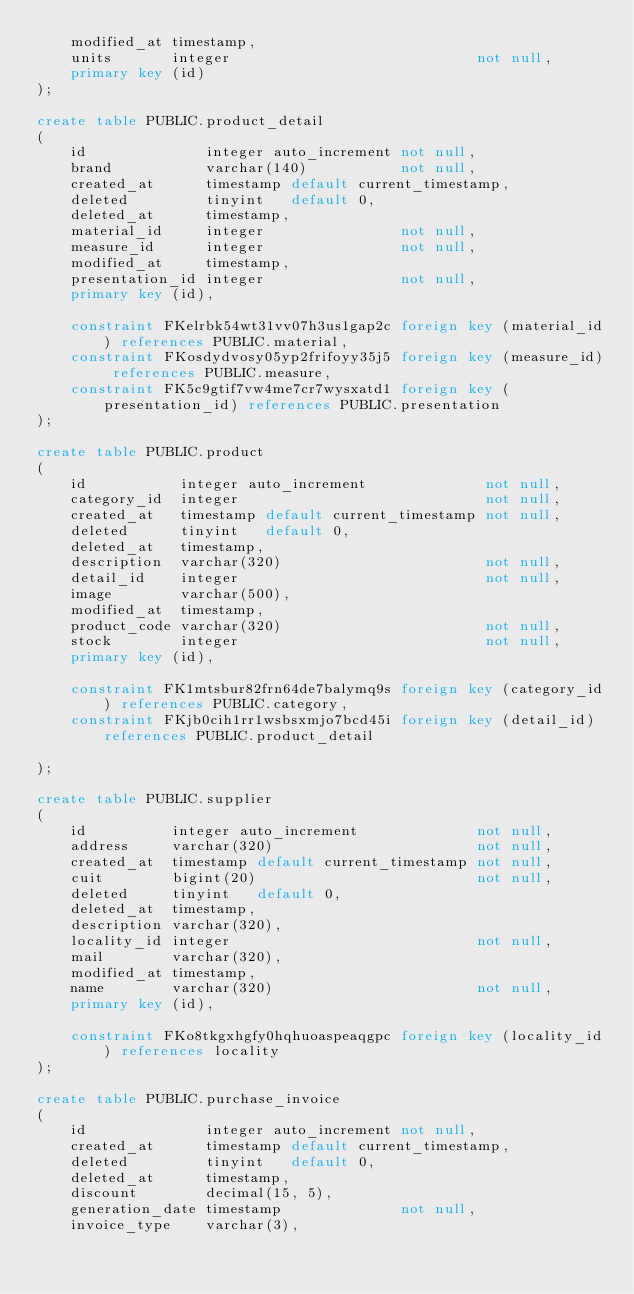Convert code to text. <code><loc_0><loc_0><loc_500><loc_500><_SQL_>    modified_at timestamp,
    units       integer                             not null,
    primary key (id)
);

create table PUBLIC.product_detail
(
    id              integer auto_increment not null,
    brand           varchar(140)           not null,
    created_at      timestamp default current_timestamp,
    deleted         tinyint   default 0,
    deleted_at      timestamp,
    material_id     integer                not null,
    measure_id      integer                not null,
    modified_at     timestamp,
    presentation_id integer                not null,
    primary key (id),

    constraint FKelrbk54wt31vv07h3us1gap2c foreign key (material_id) references PUBLIC.material,
    constraint FKosdydvosy05yp2frifoyy35j5 foreign key (measure_id) references PUBLIC.measure,
    constraint FK5c9gtif7vw4me7cr7wysxatd1 foreign key (presentation_id) references PUBLIC.presentation
);

create table PUBLIC.product
(
    id           integer auto_increment              not null,
    category_id  integer                             not null,
    created_at   timestamp default current_timestamp not null,
    deleted      tinyint   default 0,
    deleted_at   timestamp,
    description  varchar(320)                        not null,
    detail_id    integer                             not null,
    image        varchar(500),
    modified_at  timestamp,
    product_code varchar(320)                        not null,
    stock        integer                             not null,
    primary key (id),

    constraint FK1mtsbur82frn64de7balymq9s foreign key (category_id) references PUBLIC.category,
    constraint FKjb0cih1rr1wsbsxmjo7bcd45i foreign key (detail_id) references PUBLIC.product_detail

);

create table PUBLIC.supplier
(
    id          integer auto_increment              not null,
    address     varchar(320)                        not null,
    created_at  timestamp default current_timestamp not null,
    cuit        bigint(20)                          not null,
    deleted     tinyint   default 0,
    deleted_at  timestamp,
    description varchar(320),
    locality_id integer                             not null,
    mail        varchar(320),
    modified_at timestamp,
    name        varchar(320)                        not null,
    primary key (id),

    constraint FKo8tkgxhgfy0hqhuoaspeaqgpc foreign key (locality_id) references locality
);

create table PUBLIC.purchase_invoice
(
    id              integer auto_increment not null,
    created_at      timestamp default current_timestamp,
    deleted         tinyint   default 0,
    deleted_at      timestamp,
    discount        decimal(15, 5),
    generation_date timestamp              not null,
    invoice_type    varchar(3),</code> 